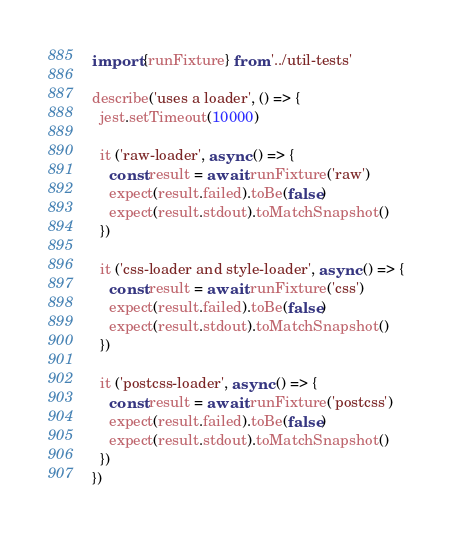Convert code to text. <code><loc_0><loc_0><loc_500><loc_500><_TypeScript_>import {runFixture} from '../util-tests'

describe('uses a loader', () => {
  jest.setTimeout(10000)

  it ('raw-loader', async () => {
    const result = await runFixture('raw')
    expect(result.failed).toBe(false)
    expect(result.stdout).toMatchSnapshot()
  })

  it ('css-loader and style-loader', async () => {
    const result = await runFixture('css')
    expect(result.failed).toBe(false)
    expect(result.stdout).toMatchSnapshot()
  })

  it ('postcss-loader', async () => {
    const result = await runFixture('postcss')
    expect(result.failed).toBe(false)
    expect(result.stdout).toMatchSnapshot()
  })
})
</code> 